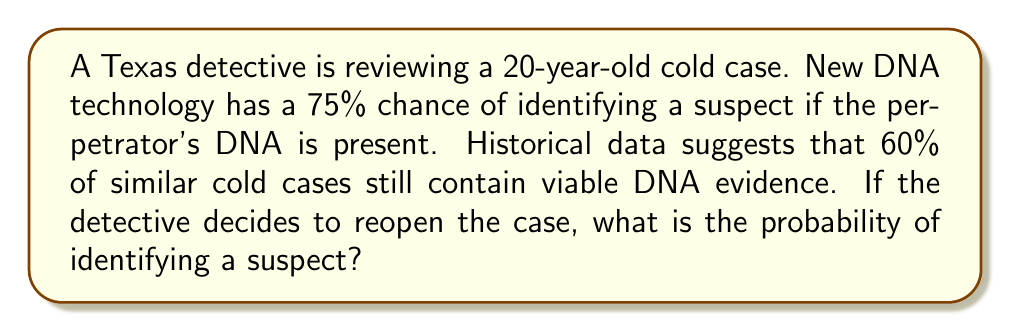Provide a solution to this math problem. Let's approach this step-by-step using probability theory:

1) Define events:
   A: The case contains viable DNA evidence
   B: A suspect is identified given that DNA evidence is present

2) Given probabilities:
   P(A) = 0.60 (60% chance of viable DNA)
   P(B|A) = 0.75 (75% chance of identifying suspect if DNA is present)

3) We want to find P(B), the probability of identifying a suspect.

4) Using the Law of Total Probability:
   $$P(B) = P(B|A) \cdot P(A) + P(B|\text{not }A) \cdot P(\text{not }A)$$

5) We know P(B|A), P(A), and P(not A):
   P(B|A) = 0.75
   P(A) = 0.60
   P(not A) = 1 - P(A) = 0.40

6) P(B|not A) = 0, because if there's no DNA, a suspect can't be identified using DNA technology.

7) Substituting into the formula:
   $$P(B) = 0.75 \cdot 0.60 + 0 \cdot 0.40 = 0.45$$

Therefore, the probability of identifying a suspect is 0.45 or 45%.
Answer: 0.45 